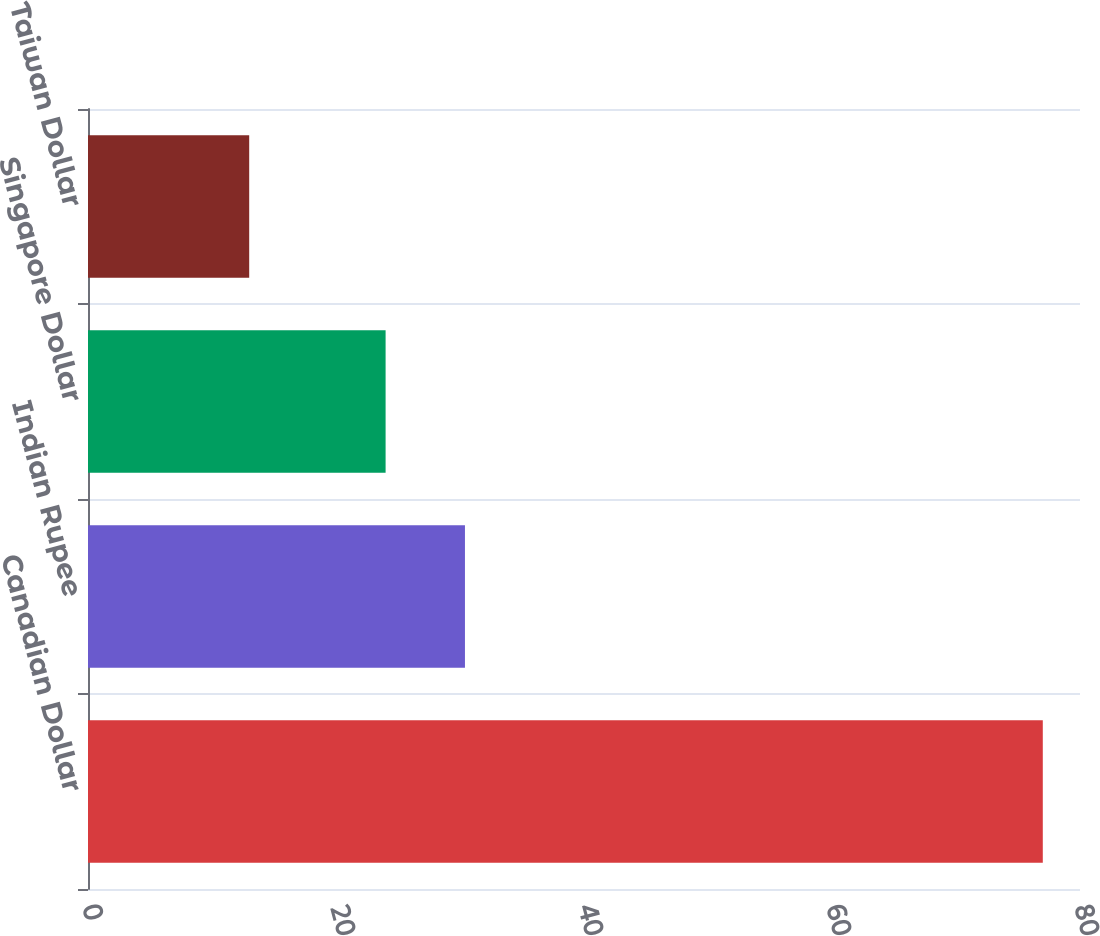Convert chart. <chart><loc_0><loc_0><loc_500><loc_500><bar_chart><fcel>Canadian Dollar<fcel>Indian Rupee<fcel>Singapore Dollar<fcel>Taiwan Dollar<nl><fcel>77<fcel>30.4<fcel>24<fcel>13<nl></chart> 